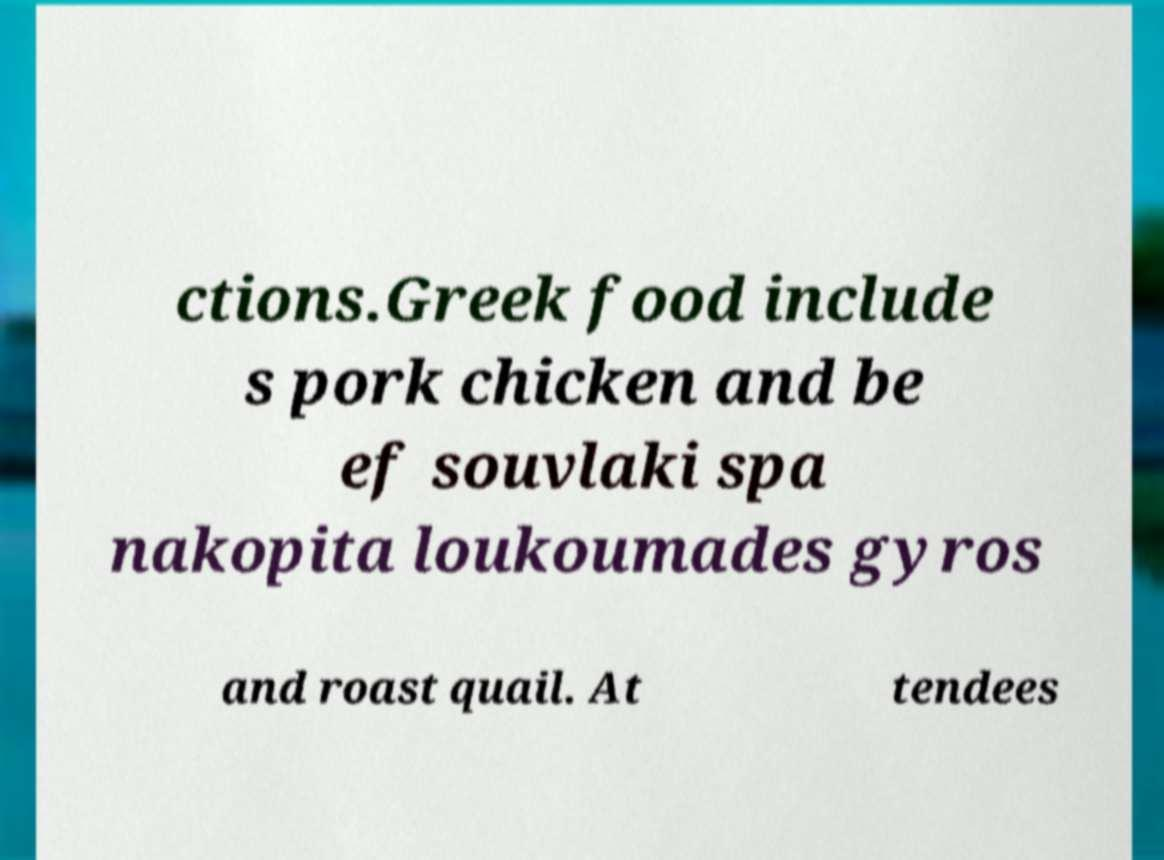I need the written content from this picture converted into text. Can you do that? ctions.Greek food include s pork chicken and be ef souvlaki spa nakopita loukoumades gyros and roast quail. At tendees 